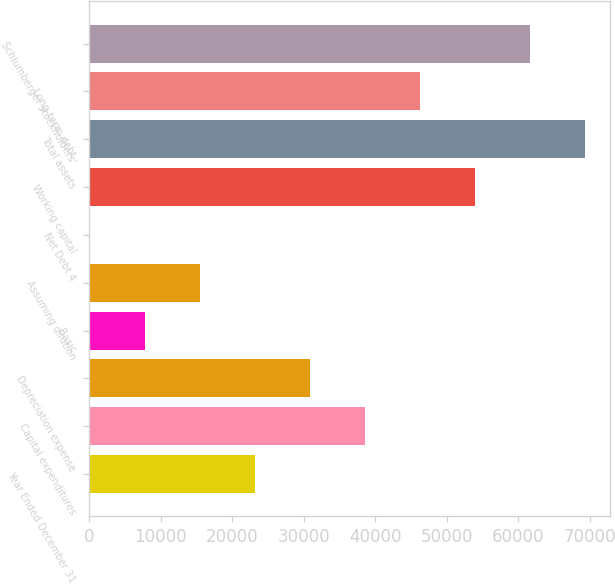Convert chart. <chart><loc_0><loc_0><loc_500><loc_500><bar_chart><fcel>Year Ended December 31<fcel>Capital expenditures<fcel>Depreciation expense<fcel>Basic<fcel>Assuming dilution<fcel>Net Debt 4<fcel>Working capital<fcel>Total assets<fcel>Long-term debt<fcel>Schlumberger stockholders'<nl><fcel>23188.2<fcel>38563<fcel>30875.6<fcel>7813.4<fcel>15500.8<fcel>126<fcel>53937.8<fcel>69312.6<fcel>46250.4<fcel>61625.2<nl></chart> 